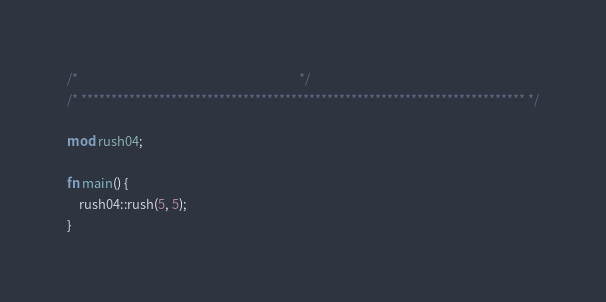Convert code to text. <code><loc_0><loc_0><loc_500><loc_500><_Rust_>/*                                                                            */
/* ************************************************************************** */

mod rush04;

fn main() {
    rush04::rush(5, 5);
}
</code> 